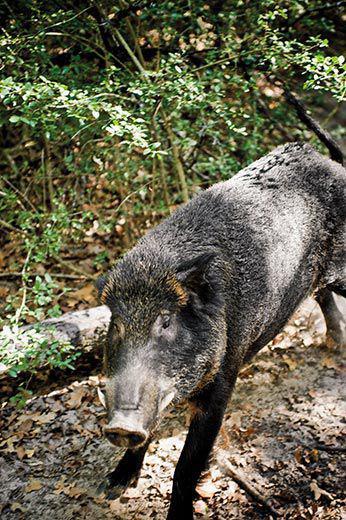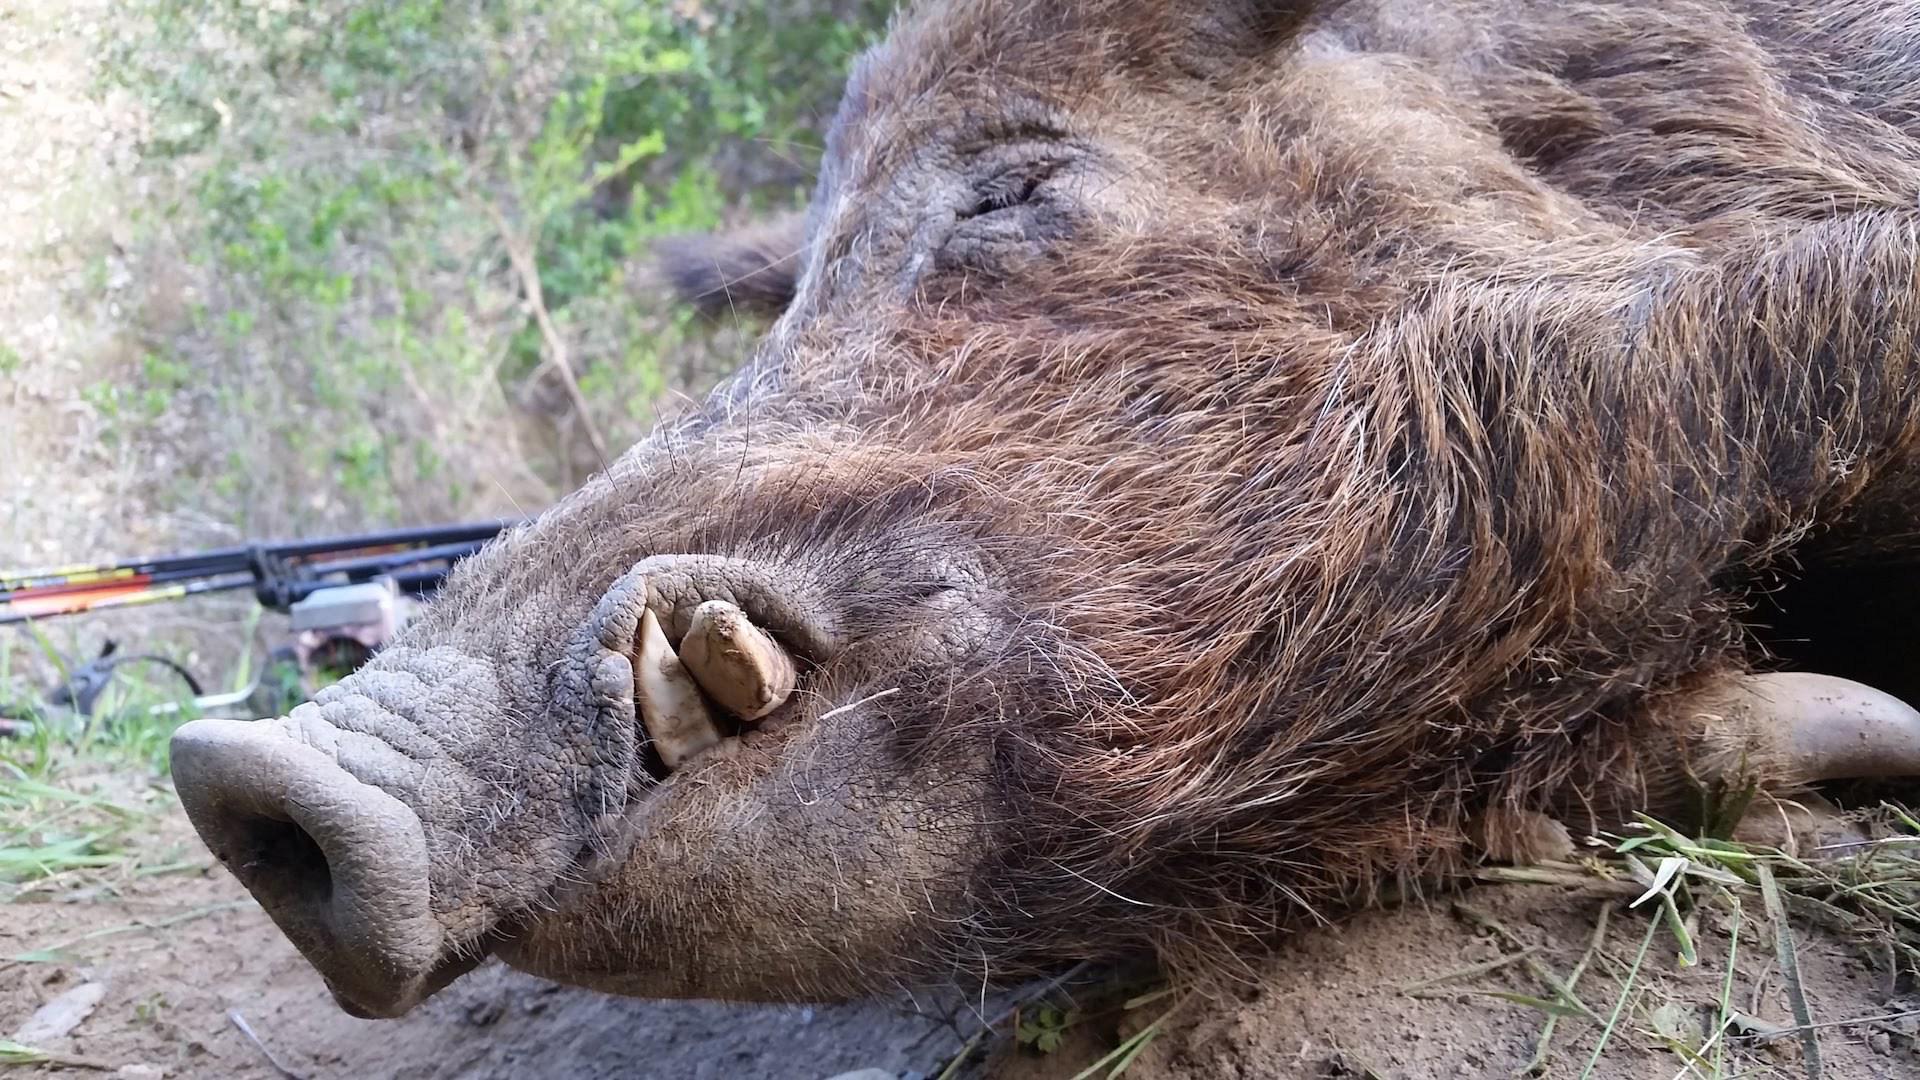The first image is the image on the left, the second image is the image on the right. Considering the images on both sides, is "There are two animals in total." valid? Answer yes or no. Yes. The first image is the image on the left, the second image is the image on the right. Examine the images to the left and right. Is the description "A weapon is visible next to a dead hog in one image." accurate? Answer yes or no. Yes. 